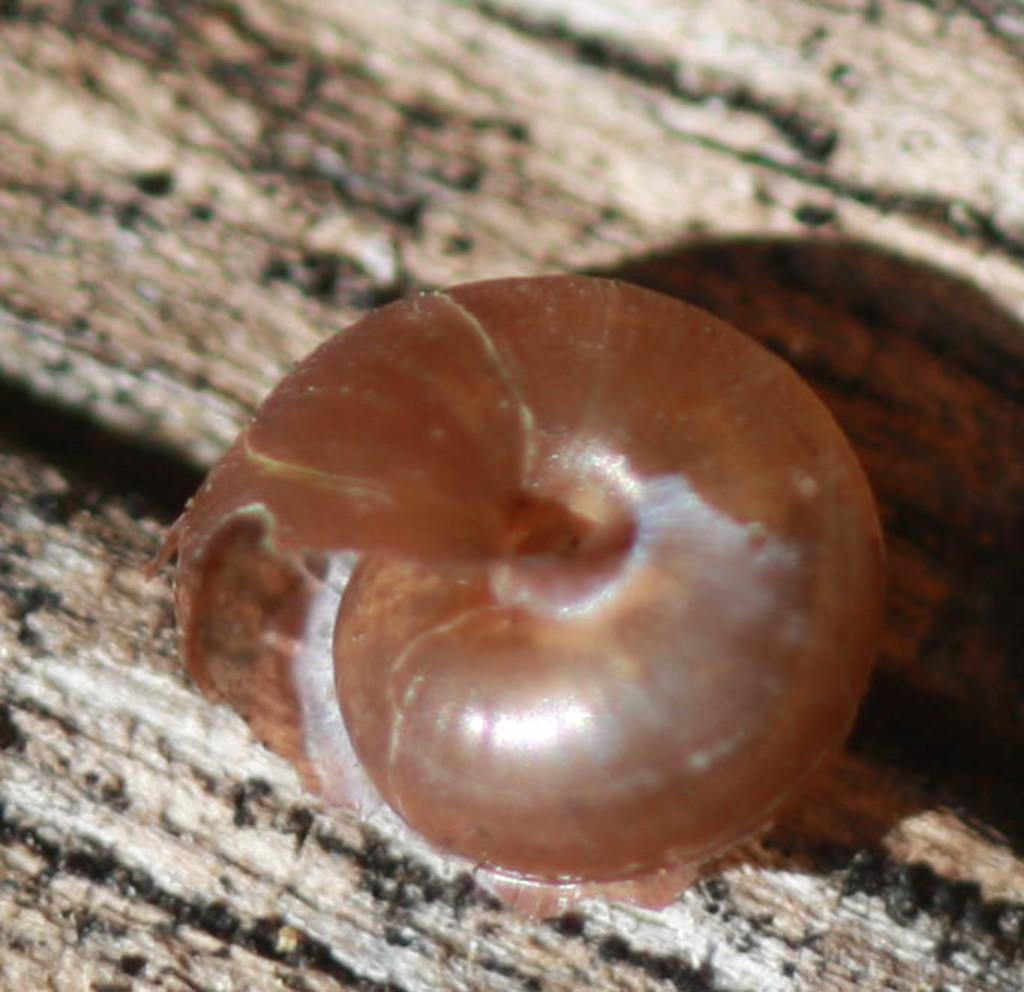What object is present in the image? There is a snail shell in the image. Where is the snail shell located? The snail shell is placed on a surface. How many springs are visible in the image? There are no springs present in the image. What is the height of the men in the image? There are no men present in the image. 